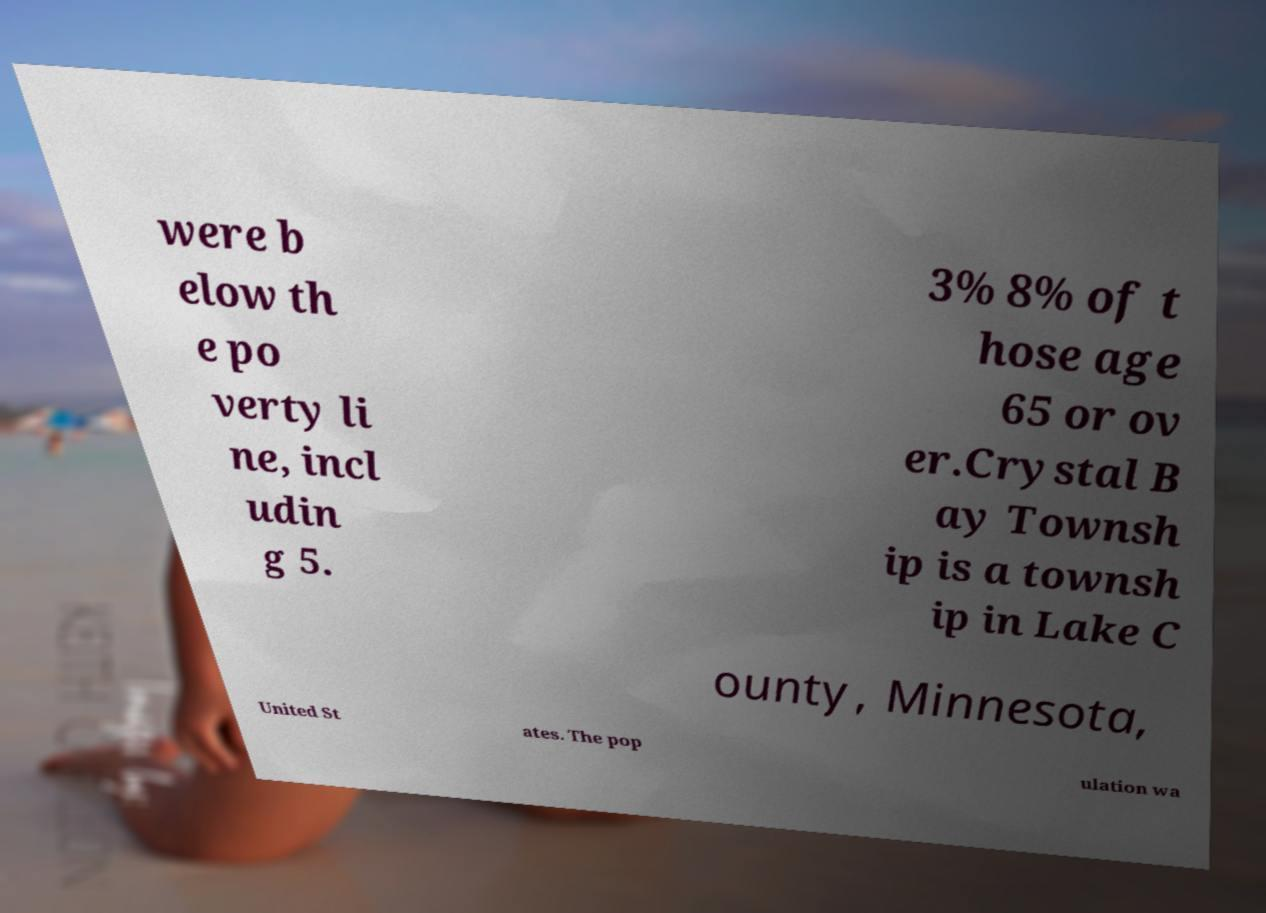Please identify and transcribe the text found in this image. were b elow th e po verty li ne, incl udin g 5. 3% 8% of t hose age 65 or ov er.Crystal B ay Townsh ip is a townsh ip in Lake C ounty, Minnesota, United St ates. The pop ulation wa 